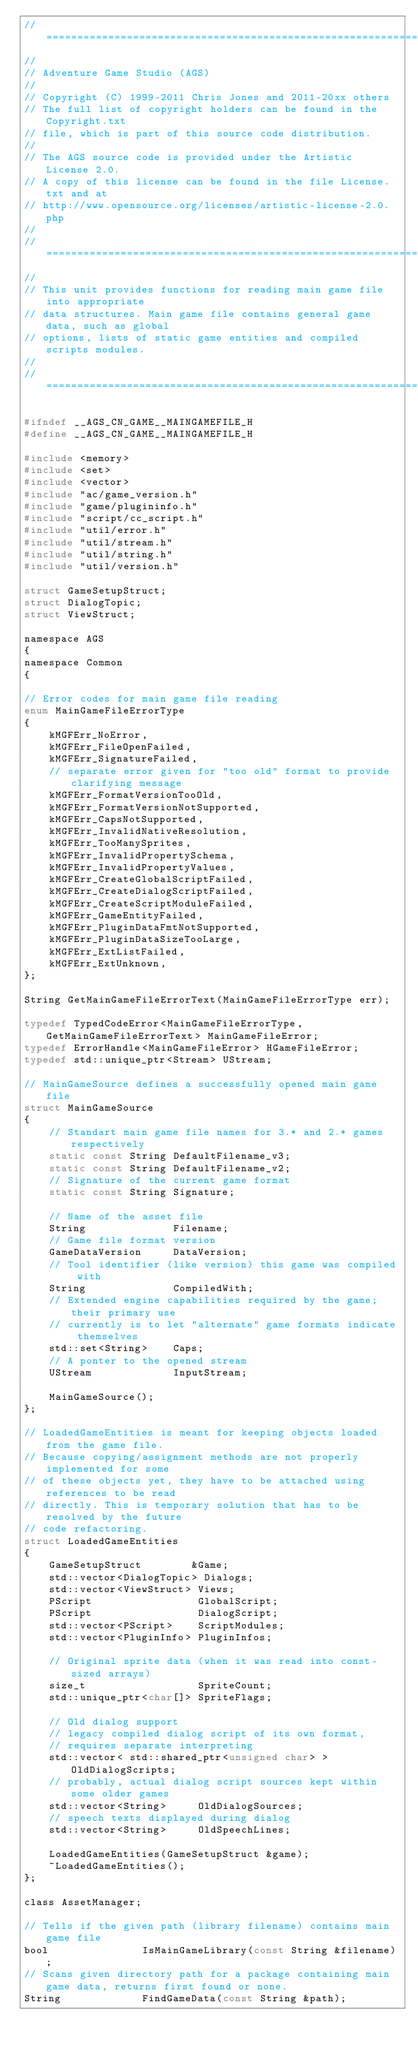Convert code to text. <code><loc_0><loc_0><loc_500><loc_500><_C_>//=============================================================================
//
// Adventure Game Studio (AGS)
//
// Copyright (C) 1999-2011 Chris Jones and 2011-20xx others
// The full list of copyright holders can be found in the Copyright.txt
// file, which is part of this source code distribution.
//
// The AGS source code is provided under the Artistic License 2.0.
// A copy of this license can be found in the file License.txt and at
// http://www.opensource.org/licenses/artistic-license-2.0.php
//
//=============================================================================
//
// This unit provides functions for reading main game file into appropriate
// data structures. Main game file contains general game data, such as global
// options, lists of static game entities and compiled scripts modules.
//
//=============================================================================

#ifndef __AGS_CN_GAME__MAINGAMEFILE_H
#define __AGS_CN_GAME__MAINGAMEFILE_H

#include <memory>
#include <set>
#include <vector>
#include "ac/game_version.h"
#include "game/plugininfo.h"
#include "script/cc_script.h"
#include "util/error.h"
#include "util/stream.h"
#include "util/string.h"
#include "util/version.h"

struct GameSetupStruct;
struct DialogTopic;
struct ViewStruct;

namespace AGS
{
namespace Common
{

// Error codes for main game file reading
enum MainGameFileErrorType
{
    kMGFErr_NoError,
    kMGFErr_FileOpenFailed,
    kMGFErr_SignatureFailed,
    // separate error given for "too old" format to provide clarifying message
    kMGFErr_FormatVersionTooOld,
    kMGFErr_FormatVersionNotSupported,
    kMGFErr_CapsNotSupported,
    kMGFErr_InvalidNativeResolution,
    kMGFErr_TooManySprites,
    kMGFErr_InvalidPropertySchema,
    kMGFErr_InvalidPropertyValues,
    kMGFErr_CreateGlobalScriptFailed,
    kMGFErr_CreateDialogScriptFailed,
    kMGFErr_CreateScriptModuleFailed,
    kMGFErr_GameEntityFailed,
    kMGFErr_PluginDataFmtNotSupported,
    kMGFErr_PluginDataSizeTooLarge,
    kMGFErr_ExtListFailed,
    kMGFErr_ExtUnknown,
};

String GetMainGameFileErrorText(MainGameFileErrorType err);

typedef TypedCodeError<MainGameFileErrorType, GetMainGameFileErrorText> MainGameFileError;
typedef ErrorHandle<MainGameFileError> HGameFileError;
typedef std::unique_ptr<Stream> UStream;

// MainGameSource defines a successfully opened main game file
struct MainGameSource
{
    // Standart main game file names for 3.* and 2.* games respectively
    static const String DefaultFilename_v3;
    static const String DefaultFilename_v2;
    // Signature of the current game format
    static const String Signature;

    // Name of the asset file
    String              Filename;
    // Game file format version
    GameDataVersion     DataVersion;
    // Tool identifier (like version) this game was compiled with
    String              CompiledWith;
    // Extended engine capabilities required by the game; their primary use
    // currently is to let "alternate" game formats indicate themselves
    std::set<String>    Caps;
    // A ponter to the opened stream
    UStream             InputStream;

    MainGameSource();
};

// LoadedGameEntities is meant for keeping objects loaded from the game file.
// Because copying/assignment methods are not properly implemented for some
// of these objects yet, they have to be attached using references to be read
// directly. This is temporary solution that has to be resolved by the future
// code refactoring.
struct LoadedGameEntities
{
    GameSetupStruct        &Game;
    std::vector<DialogTopic> Dialogs;
    std::vector<ViewStruct> Views;
    PScript                 GlobalScript;
    PScript                 DialogScript;
    std::vector<PScript>    ScriptModules;
    std::vector<PluginInfo> PluginInfos;

    // Original sprite data (when it was read into const-sized arrays)
    size_t                  SpriteCount;
    std::unique_ptr<char[]> SpriteFlags;

    // Old dialog support
    // legacy compiled dialog script of its own format,
    // requires separate interpreting
    std::vector< std::shared_ptr<unsigned char> > OldDialogScripts;
    // probably, actual dialog script sources kept within some older games
    std::vector<String>     OldDialogSources;
    // speech texts displayed during dialog
    std::vector<String>     OldSpeechLines;

    LoadedGameEntities(GameSetupStruct &game);
    ~LoadedGameEntities();
};

class AssetManager;

// Tells if the given path (library filename) contains main game file
bool               IsMainGameLibrary(const String &filename);
// Scans given directory path for a package containing main game data, returns first found or none.
String             FindGameData(const String &path);</code> 